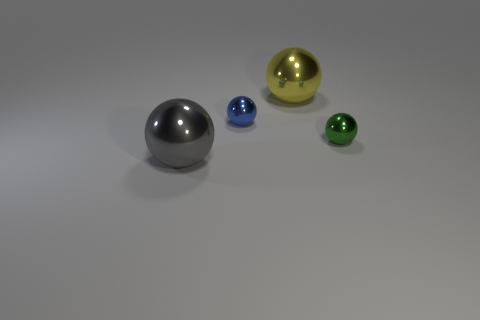Subtract all red balls. Subtract all brown cylinders. How many balls are left? 4 Add 2 tiny balls. How many objects exist? 6 Add 1 large gray shiny things. How many large gray shiny things exist? 2 Subtract 0 purple cylinders. How many objects are left? 4 Subtract all small blocks. Subtract all small green balls. How many objects are left? 3 Add 1 green metal things. How many green metal things are left? 2 